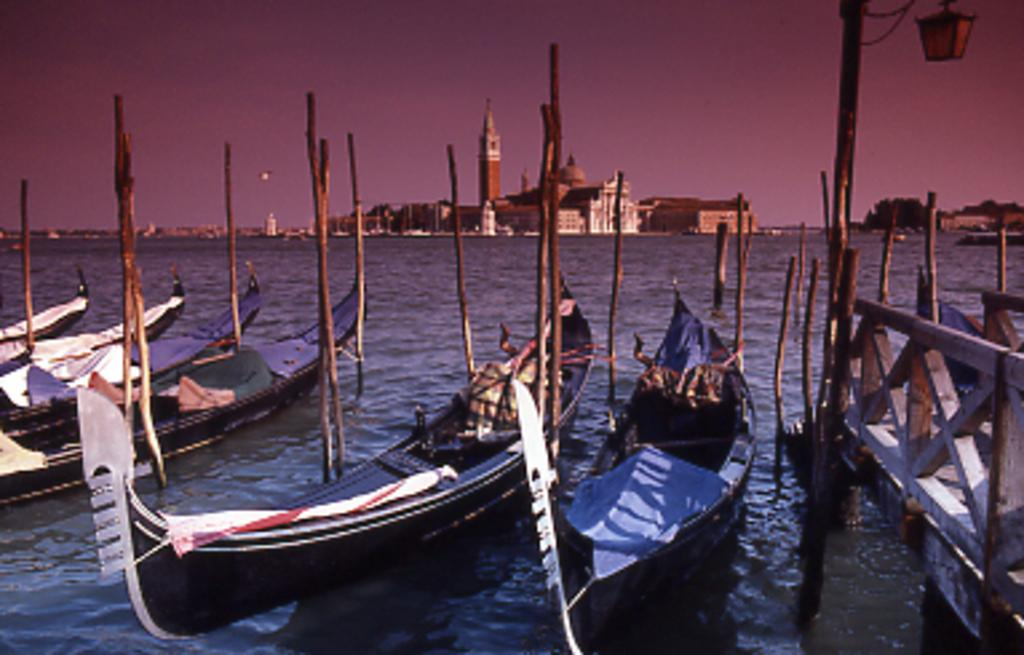What type of vehicles can be seen in the water in the image? There are boats in the water in the image. What structure is present in the image that allows people or vehicles to cross over the water? There is a bridge in the image. What can be seen in the distance behind the bridge? There are buildings visible in the background. What part of the natural environment is visible in the image? The sky is visible in the image. What type of bell can be heard ringing in the image? There is no bell present in the image, and therefore no sound can be heard. What type of work is being done on the bridge in the image? There is no indication of any work being done on the bridge in the image. 